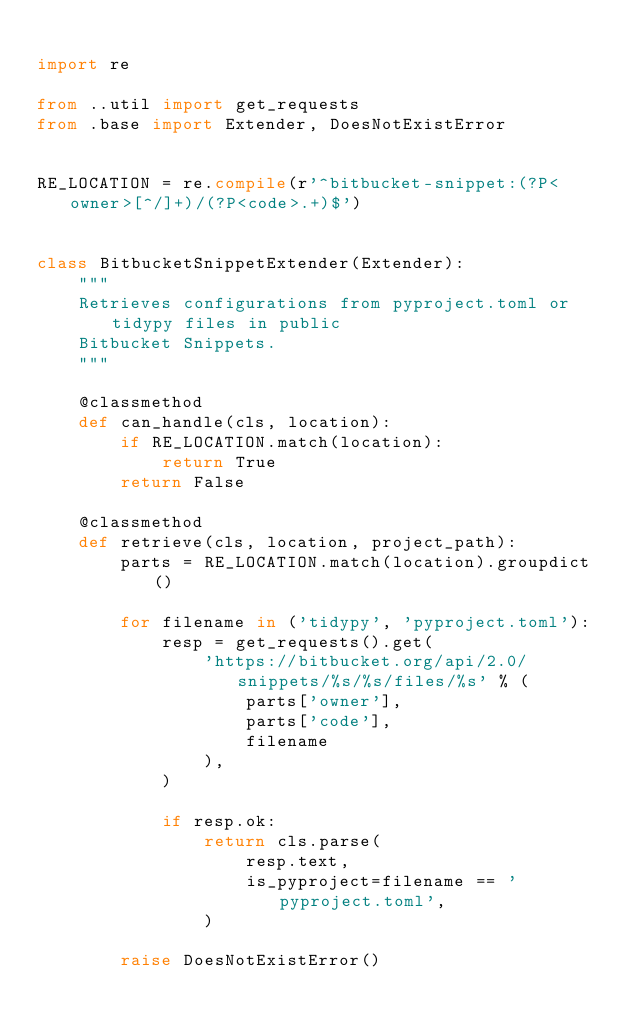Convert code to text. <code><loc_0><loc_0><loc_500><loc_500><_Python_>
import re

from ..util import get_requests
from .base import Extender, DoesNotExistError


RE_LOCATION = re.compile(r'^bitbucket-snippet:(?P<owner>[^/]+)/(?P<code>.+)$')


class BitbucketSnippetExtender(Extender):
    """
    Retrieves configurations from pyproject.toml or tidypy files in public
    Bitbucket Snippets.
    """

    @classmethod
    def can_handle(cls, location):
        if RE_LOCATION.match(location):
            return True
        return False

    @classmethod
    def retrieve(cls, location, project_path):
        parts = RE_LOCATION.match(location).groupdict()

        for filename in ('tidypy', 'pyproject.toml'):
            resp = get_requests().get(
                'https://bitbucket.org/api/2.0/snippets/%s/%s/files/%s' % (
                    parts['owner'],
                    parts['code'],
                    filename
                ),
            )

            if resp.ok:
                return cls.parse(
                    resp.text,
                    is_pyproject=filename == 'pyproject.toml',
                )

        raise DoesNotExistError()

</code> 